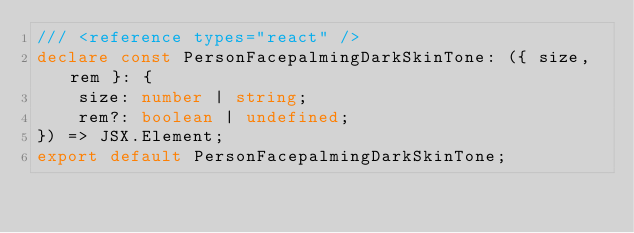Convert code to text. <code><loc_0><loc_0><loc_500><loc_500><_TypeScript_>/// <reference types="react" />
declare const PersonFacepalmingDarkSkinTone: ({ size, rem }: {
    size: number | string;
    rem?: boolean | undefined;
}) => JSX.Element;
export default PersonFacepalmingDarkSkinTone;
</code> 